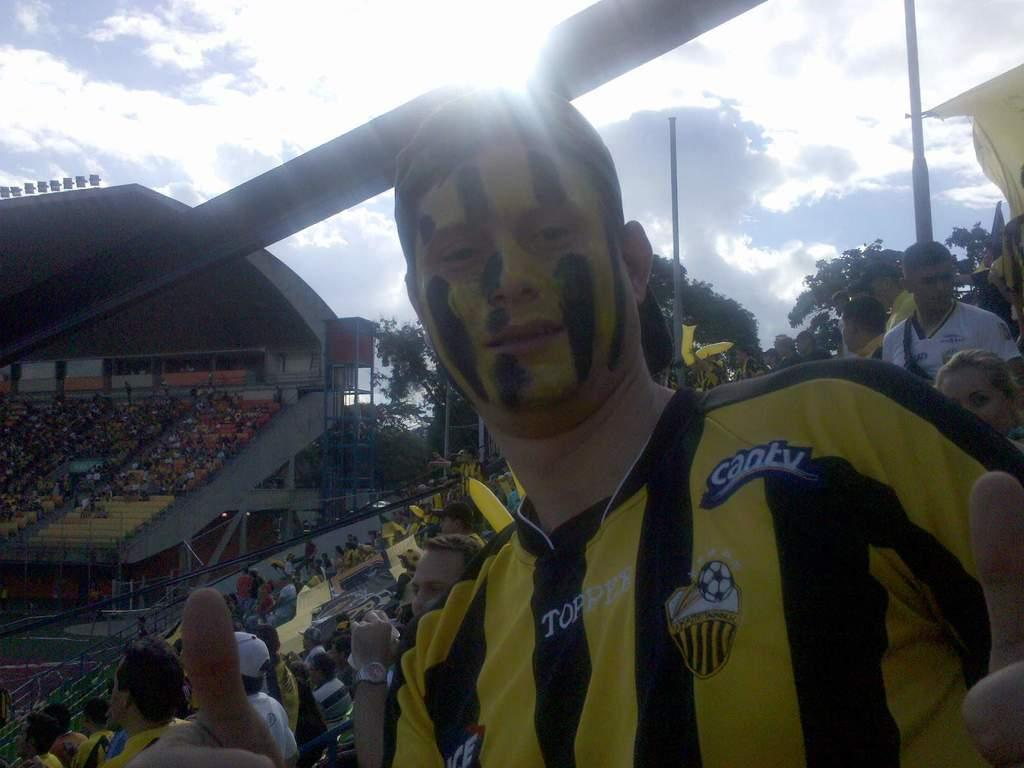Provide a one-sentence caption for the provided image. A soccer fan wearing a black and yellow striped soccer jersey sitting in a stadium full of people. 